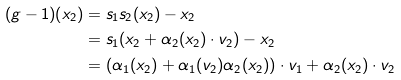Convert formula to latex. <formula><loc_0><loc_0><loc_500><loc_500>( g - 1 ) ( x _ { 2 } ) & = s _ { 1 } s _ { 2 } ( x _ { 2 } ) - x _ { 2 } \\ & = s _ { 1 } ( x _ { 2 } + \alpha _ { 2 } ( x _ { 2 } ) \cdot v _ { 2 } ) - x _ { 2 } \\ & = ( \alpha _ { 1 } ( x _ { 2 } ) + \alpha _ { 1 } ( v _ { 2 } ) \alpha _ { 2 } ( x _ { 2 } ) ) \cdot v _ { 1 } + \alpha _ { 2 } ( x _ { 2 } ) \cdot v _ { 2 }</formula> 